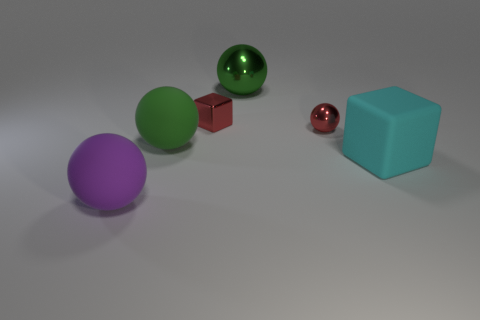Subtract all gray cubes. How many green balls are left? 2 Subtract all big purple balls. How many balls are left? 3 Add 1 things. How many objects exist? 7 Subtract all red spheres. How many spheres are left? 3 Subtract all purple balls. Subtract all purple cylinders. How many balls are left? 3 Subtract all blocks. How many objects are left? 4 Add 4 large cyan shiny cubes. How many large cyan shiny cubes exist? 4 Subtract 0 purple cylinders. How many objects are left? 6 Subtract all small cubes. Subtract all large matte cylinders. How many objects are left? 5 Add 6 green shiny objects. How many green shiny objects are left? 7 